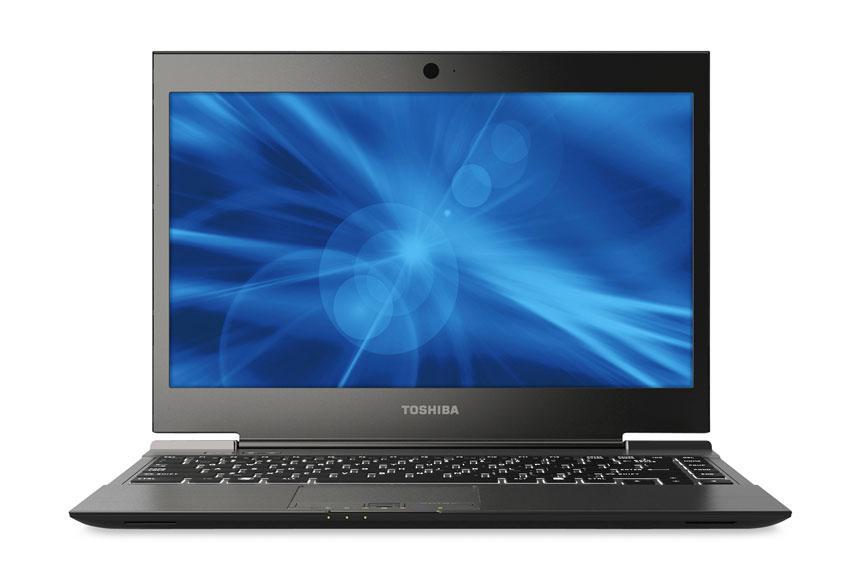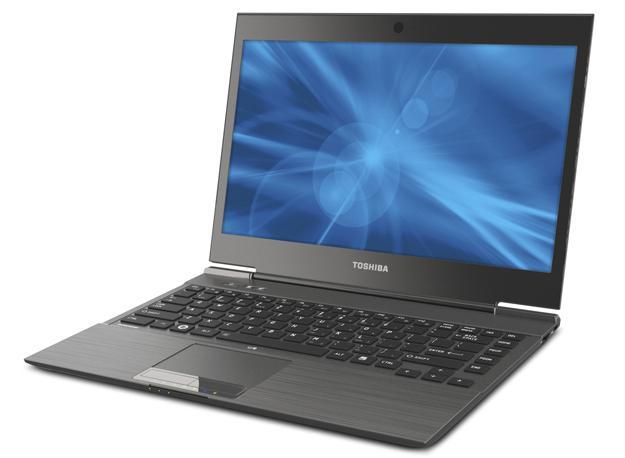The first image is the image on the left, the second image is the image on the right. For the images displayed, is the sentence "The computer displays have the same background image." factually correct? Answer yes or no. Yes. The first image is the image on the left, the second image is the image on the right. For the images displayed, is the sentence "The open laptop on the left is viewed head-on, and the open laptop on the right is displayed at an angle." factually correct? Answer yes or no. Yes. 